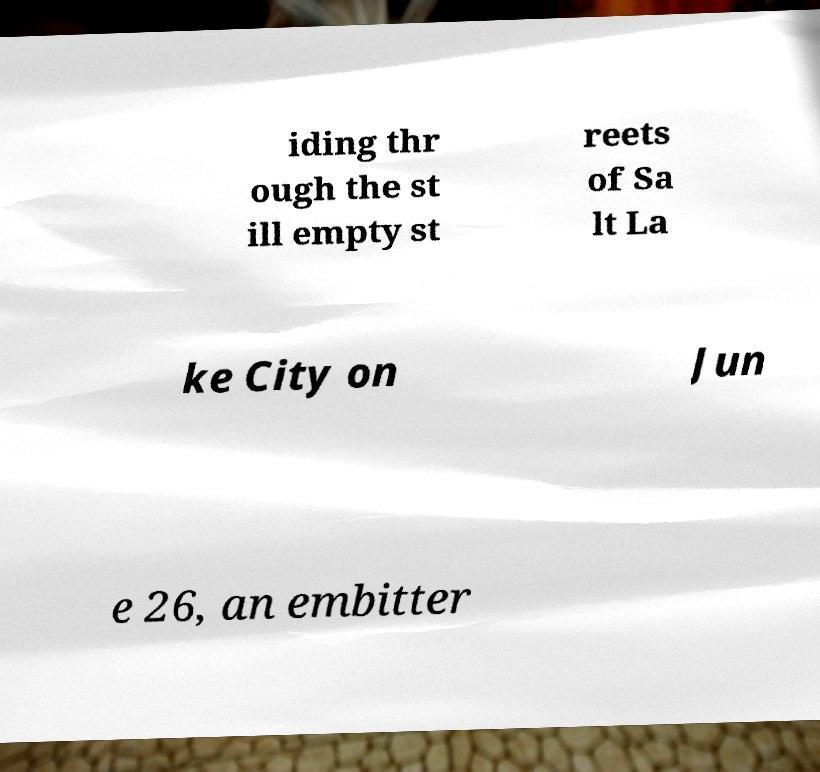Please identify and transcribe the text found in this image. iding thr ough the st ill empty st reets of Sa lt La ke City on Jun e 26, an embitter 